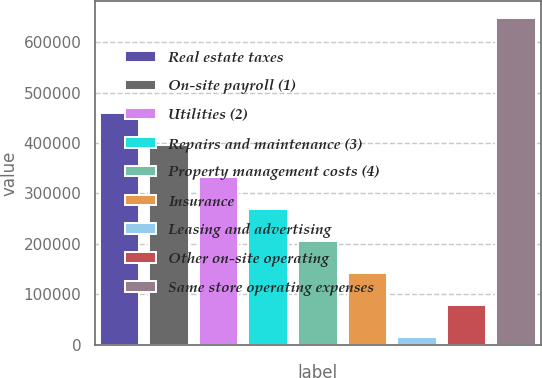Convert chart. <chart><loc_0><loc_0><loc_500><loc_500><bar_chart><fcel>Real estate taxes<fcel>On-site payroll (1)<fcel>Utilities (2)<fcel>Repairs and maintenance (3)<fcel>Property management costs (4)<fcel>Insurance<fcel>Leasing and advertising<fcel>Other on-site operating<fcel>Same store operating expenses<nl><fcel>458764<fcel>395516<fcel>332268<fcel>269021<fcel>205773<fcel>142525<fcel>16029<fcel>79276.9<fcel>648508<nl></chart> 